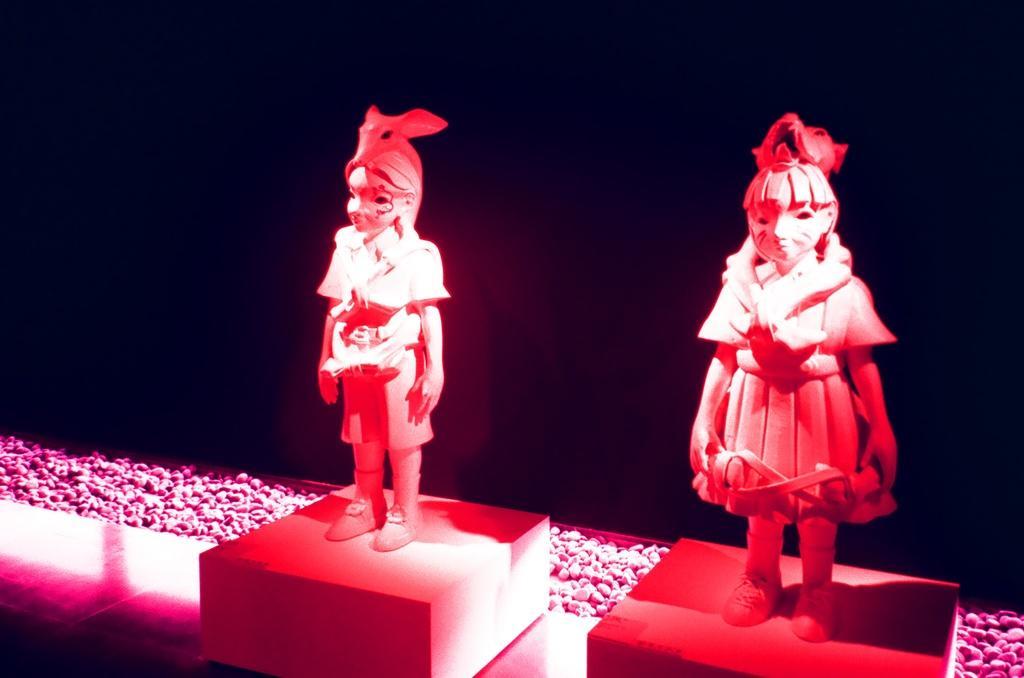Describe this image in one or two sentences. In this image I can see two persons statue on the floor. In the background I can see stones and it is dark in color. This image is taken in a hall during night. 